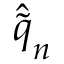<formula> <loc_0><loc_0><loc_500><loc_500>\hat { \tilde { q } } _ { n }</formula> 